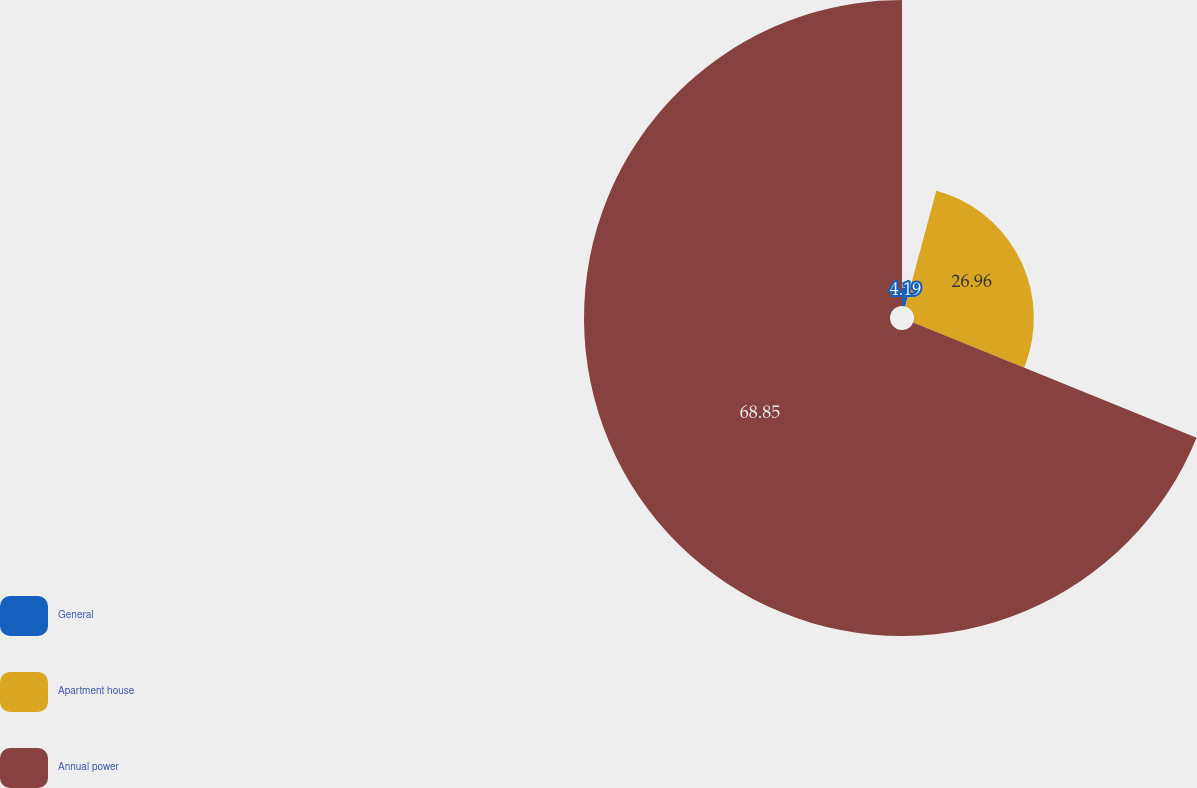Convert chart. <chart><loc_0><loc_0><loc_500><loc_500><pie_chart><fcel>General<fcel>Apartment house<fcel>Annual power<nl><fcel>4.19%<fcel>26.96%<fcel>68.85%<nl></chart> 